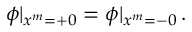Convert formula to latex. <formula><loc_0><loc_0><loc_500><loc_500>\phi | _ { x ^ { m } = + 0 } = \phi | _ { x ^ { m } = - 0 } \, .</formula> 